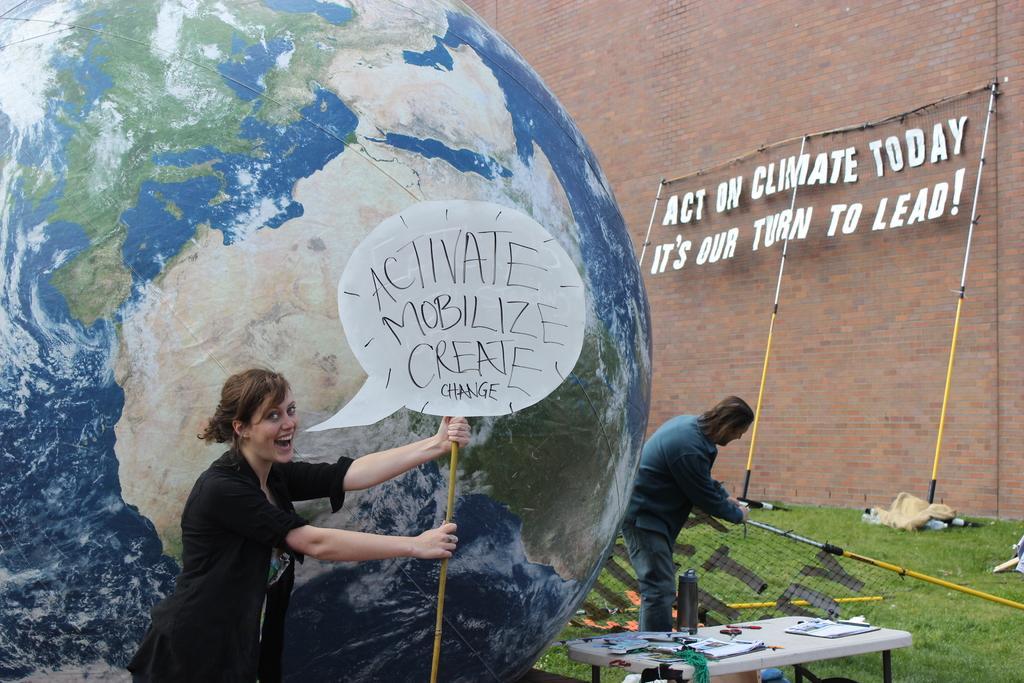Can you describe this image briefly? There is a depiction of earth in the image. There is a lady holding a placard. In the background of the image there is wall. There is a man holding a object in his hand. At the bottom of the image there is grass. There is a table on which there are many objects. 